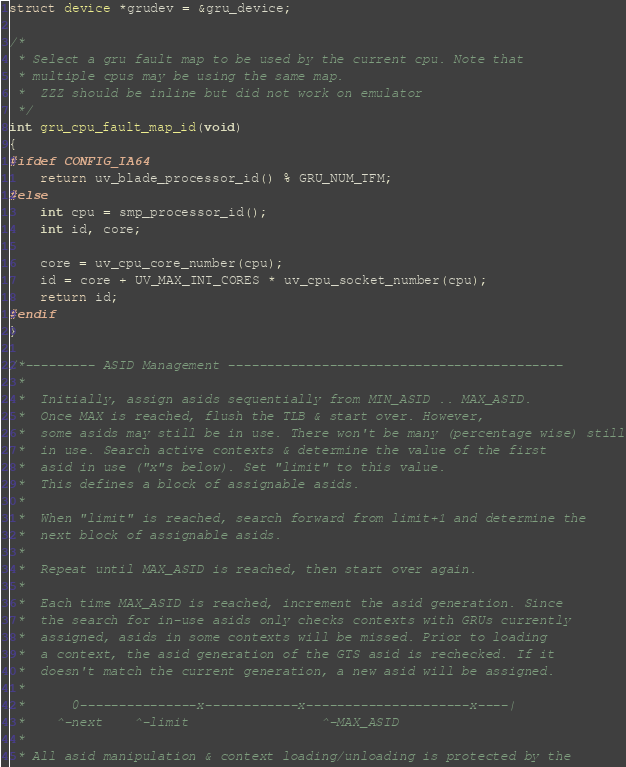<code> <loc_0><loc_0><loc_500><loc_500><_C_>struct device *grudev = &gru_device;

/*
 * Select a gru fault map to be used by the current cpu. Note that
 * multiple cpus may be using the same map.
 *	ZZZ should be inline but did not work on emulator
 */
int gru_cpu_fault_map_id(void)
{
#ifdef CONFIG_IA64
	return uv_blade_processor_id() % GRU_NUM_TFM;
#else
	int cpu = smp_processor_id();
	int id, core;

	core = uv_cpu_core_number(cpu);
	id = core + UV_MAX_INT_CORES * uv_cpu_socket_number(cpu);
	return id;
#endif
}

/*--------- ASID Management -------------------------------------------
 *
 *  Initially, assign asids sequentially from MIN_ASID .. MAX_ASID.
 *  Once MAX is reached, flush the TLB & start over. However,
 *  some asids may still be in use. There won't be many (percentage wise) still
 *  in use. Search active contexts & determine the value of the first
 *  asid in use ("x"s below). Set "limit" to this value.
 *  This defines a block of assignable asids.
 *
 *  When "limit" is reached, search forward from limit+1 and determine the
 *  next block of assignable asids.
 *
 *  Repeat until MAX_ASID is reached, then start over again.
 *
 *  Each time MAX_ASID is reached, increment the asid generation. Since
 *  the search for in-use asids only checks contexts with GRUs currently
 *  assigned, asids in some contexts will be missed. Prior to loading
 *  a context, the asid generation of the GTS asid is rechecked. If it
 *  doesn't match the current generation, a new asid will be assigned.
 *
 *   	0---------------x------------x---------------------x----|
 *	  ^-next	^-limit	   				^-MAX_ASID
 *
 * All asid manipulation & context loading/unloading is protected by the</code> 